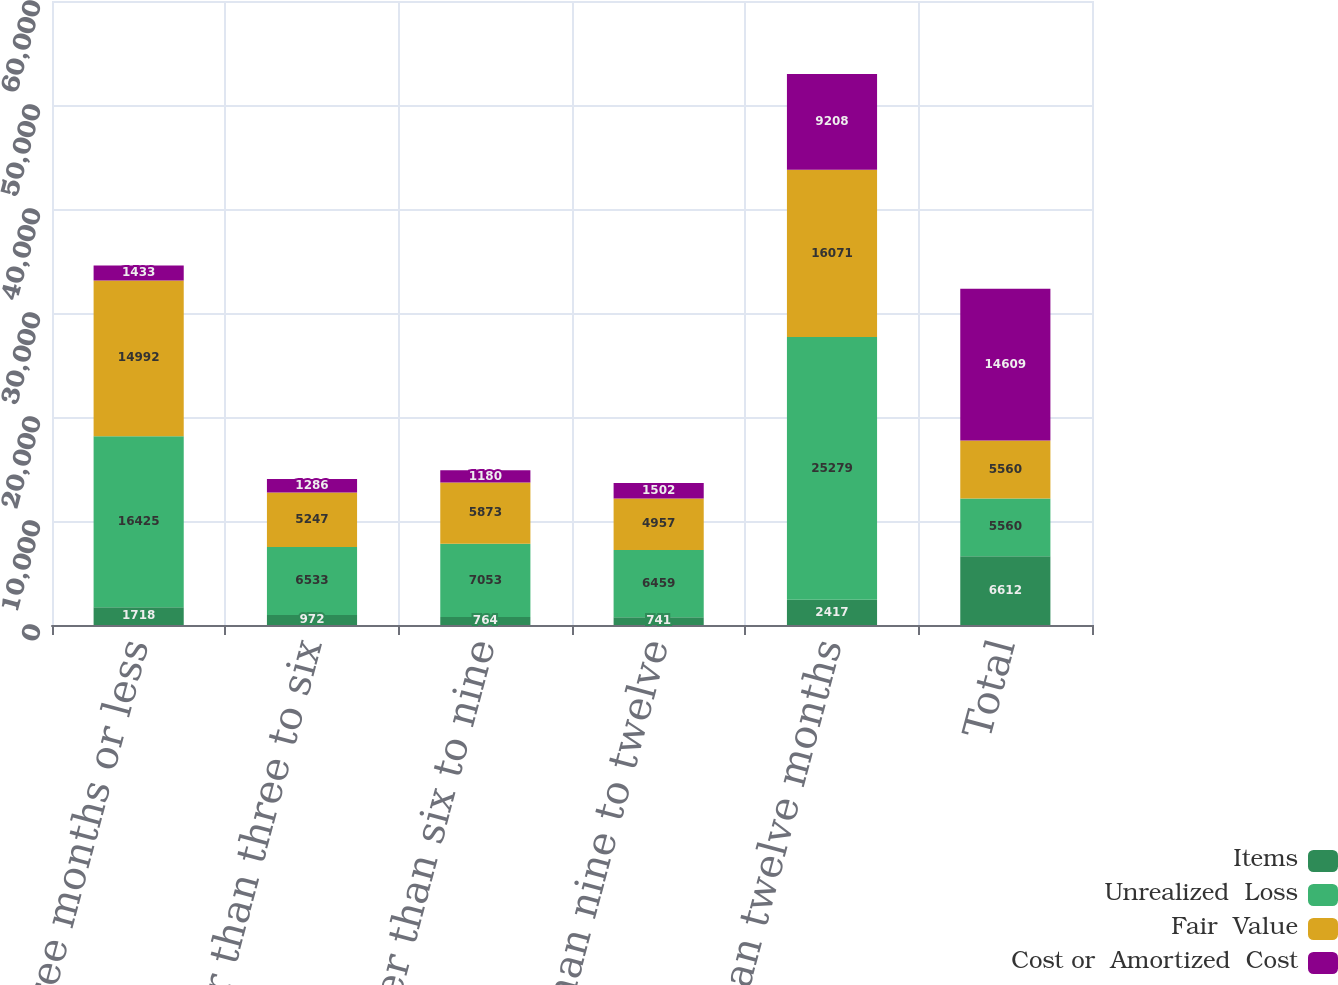Convert chart to OTSL. <chart><loc_0><loc_0><loc_500><loc_500><stacked_bar_chart><ecel><fcel>Three months or less<fcel>Greater than three to six<fcel>Greater than six to nine<fcel>Greater than nine to twelve<fcel>Greater than twelve months<fcel>Total<nl><fcel>Items<fcel>1718<fcel>972<fcel>764<fcel>741<fcel>2417<fcel>6612<nl><fcel>Unrealized  Loss<fcel>16425<fcel>6533<fcel>7053<fcel>6459<fcel>25279<fcel>5560<nl><fcel>Fair  Value<fcel>14992<fcel>5247<fcel>5873<fcel>4957<fcel>16071<fcel>5560<nl><fcel>Cost or  Amortized  Cost<fcel>1433<fcel>1286<fcel>1180<fcel>1502<fcel>9208<fcel>14609<nl></chart> 